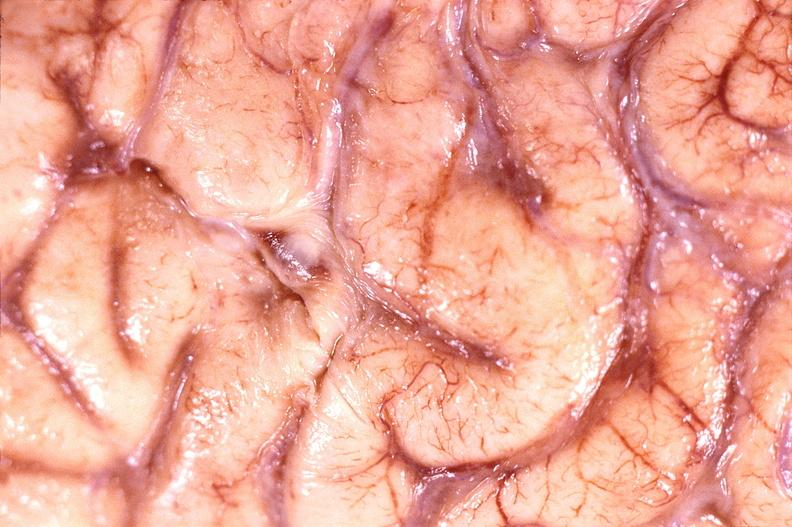does this image show brain abscess?
Answer the question using a single word or phrase. Yes 